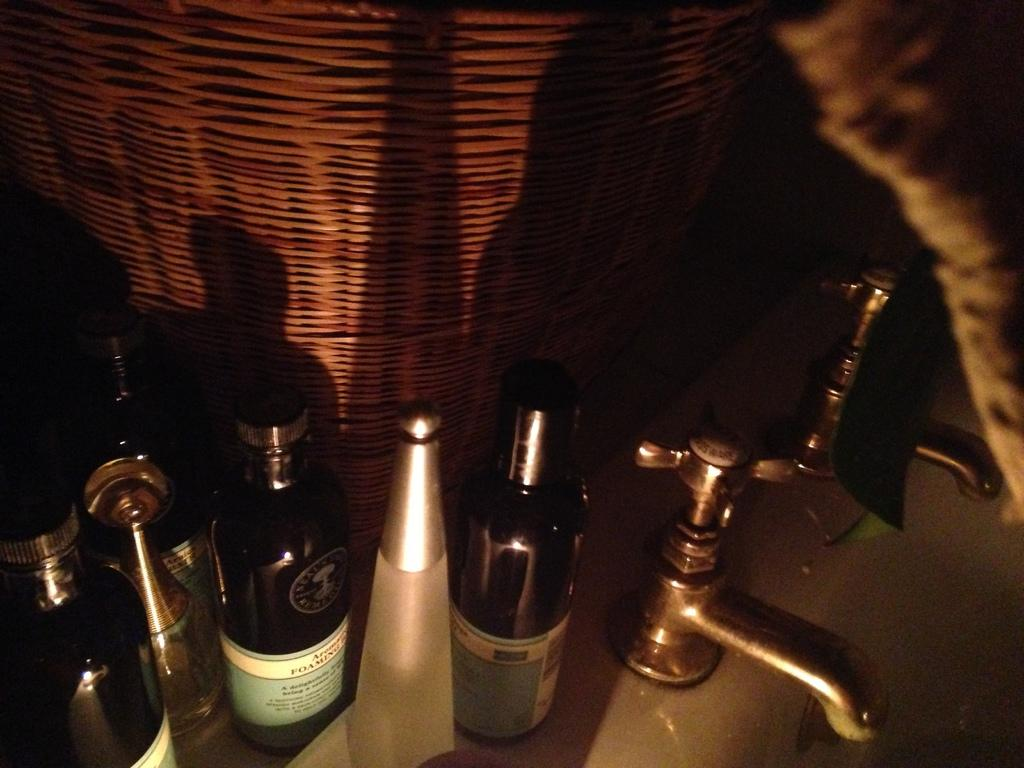What is located in the foreground of the image? There is a wash basin in the foreground of the image. What can be seen on the wash basin? There are bottles on the wash basin. What is visible in the background of the image? There is a basket in the background of the image. Where is the nest located in the image? There is no nest present in the image. What type of bulb can be seen illuminating the sidewalk in the image? There is no sidewalk or bulb present in the image. 